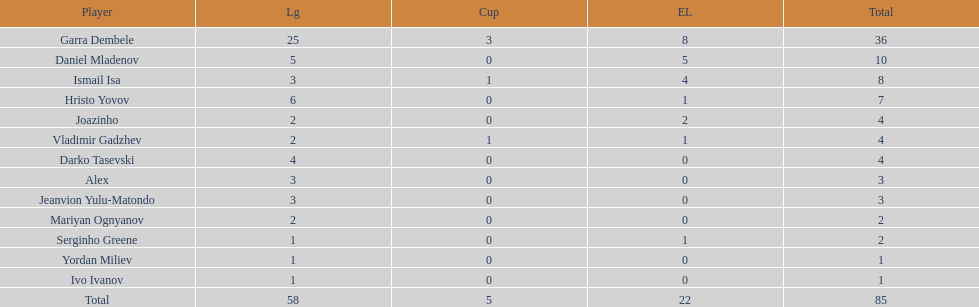Which is the only player from germany? Jeanvion Yulu-Matondo. 